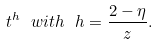Convert formula to latex. <formula><loc_0><loc_0><loc_500><loc_500>t ^ { h } \ w i t h \ h = \frac { 2 - \eta } { z } .</formula> 